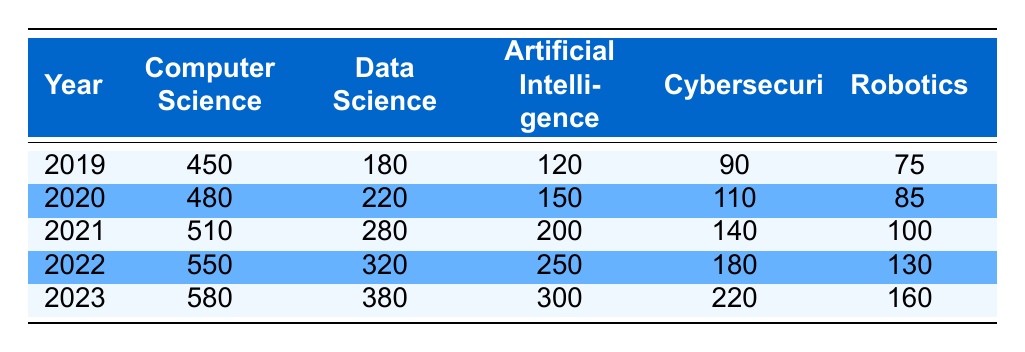What was the enrollment in Computer Science in 2021? The table shows that the enrollment in Computer Science for the year 2021 is listed under that column, which indicates 510 students.
Answer: 510 Which technology-related course had the highest number of enrollments in 2023? By examining the 2023 enrollments, we see the numbers: Computer Science (580), Data Science (380), Artificial Intelligence (300), Cybersecurity (220), Robotics (160). Computer Science has the highest number at 580.
Answer: Computer Science What is the total enrollment in Data Science over the 5 years? To find the total enrollment in Data Science, we add the yearly enrollments: 180 (2019) + 220 (2020) + 280 (2021) + 320 (2022) + 380 (2023) = 1380.
Answer: 1380 Did the enrollment in Cybersecurity increase every year? The enrollments across the years are: 90 (2019), 110 (2020), 140 (2021), 180 (2022), 220 (2023). Each year shows an increase from the previous year, confirming that enrollment did increase every year.
Answer: Yes What was the percentage increase in enrollments for Robotics from 2019 to 2023? The enrollment in Robotics increased from 75 in 2019 to 160 in 2023. The difference is 160 - 75 = 85. To find the percentage increase: (85 / 75) * 100 = 113.33%.
Answer: 113.33% 